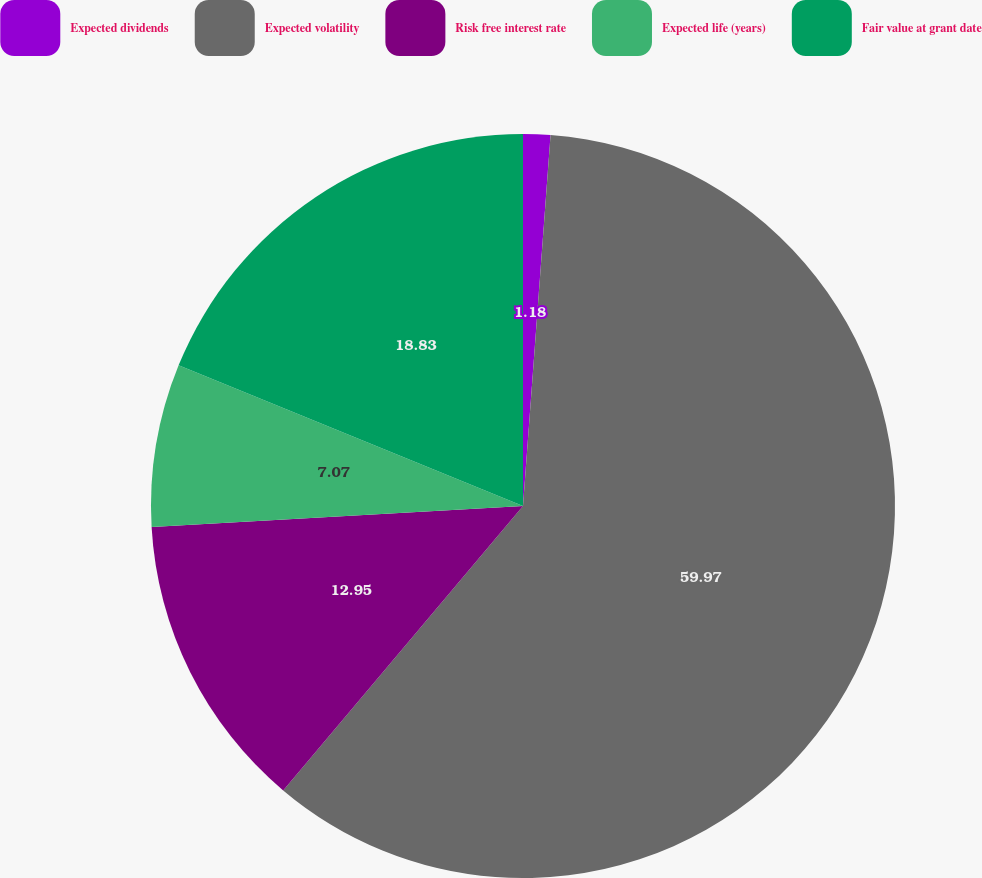Convert chart to OTSL. <chart><loc_0><loc_0><loc_500><loc_500><pie_chart><fcel>Expected dividends<fcel>Expected volatility<fcel>Risk free interest rate<fcel>Expected life (years)<fcel>Fair value at grant date<nl><fcel>1.18%<fcel>59.97%<fcel>12.95%<fcel>7.07%<fcel>18.83%<nl></chart> 